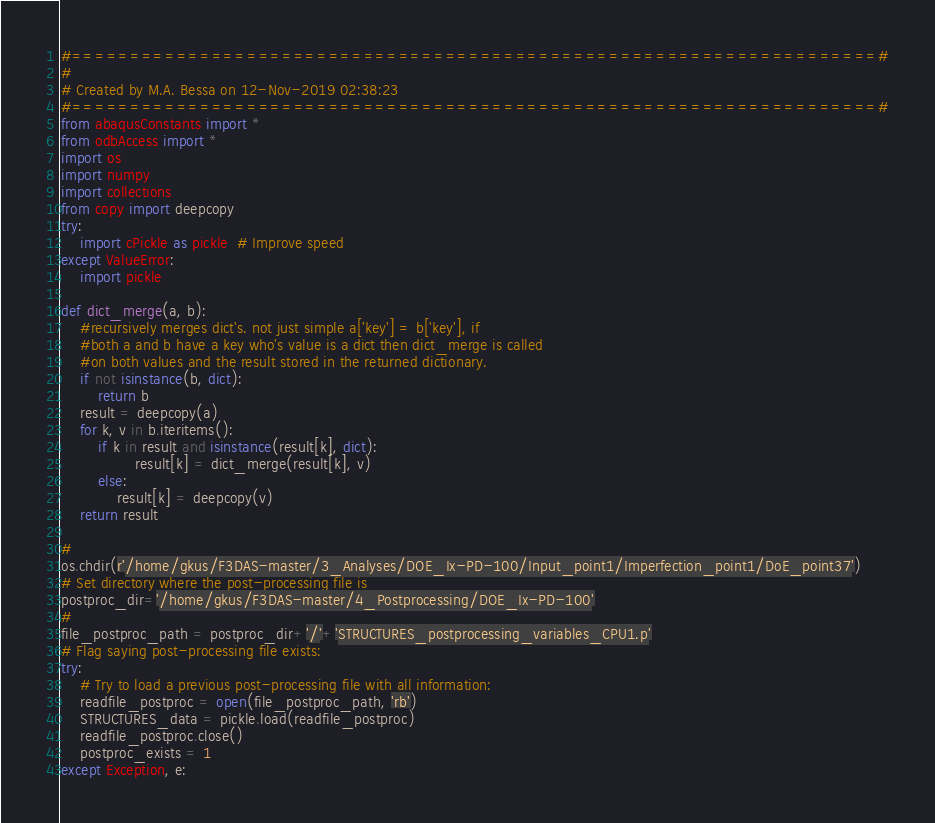<code> <loc_0><loc_0><loc_500><loc_500><_Python_>#=====================================================================#
#
# Created by M.A. Bessa on 12-Nov-2019 02:38:23
#=====================================================================#
from abaqusConstants import *
from odbAccess import *
import os
import numpy
import collections
from copy import deepcopy
try:
    import cPickle as pickle  # Improve speed
except ValueError:
    import pickle

def dict_merge(a, b):
    #recursively merges dict's. not just simple a['key'] = b['key'], if
    #both a and b have a key who's value is a dict then dict_merge is called
    #on both values and the result stored in the returned dictionary.
    if not isinstance(b, dict):
        return b
    result = deepcopy(a)
    for k, v in b.iteritems():
        if k in result and isinstance(result[k], dict):
                result[k] = dict_merge(result[k], v)
        else:
            result[k] = deepcopy(v)
    return result

#
os.chdir(r'/home/gkus/F3DAS-master/3_Analyses/DOE_Ix-PD-100/Input_point1/Imperfection_point1/DoE_point37')
# Set directory where the post-processing file is
postproc_dir='/home/gkus/F3DAS-master/4_Postprocessing/DOE_Ix-PD-100'
#
file_postproc_path = postproc_dir+'/'+'STRUCTURES_postprocessing_variables_CPU1.p'
# Flag saying post-processing file exists:
try:
    # Try to load a previous post-processing file with all information:
    readfile_postproc = open(file_postproc_path, 'rb')
    STRUCTURES_data = pickle.load(readfile_postproc)
    readfile_postproc.close()
    postproc_exists = 1
except Exception, e:</code> 